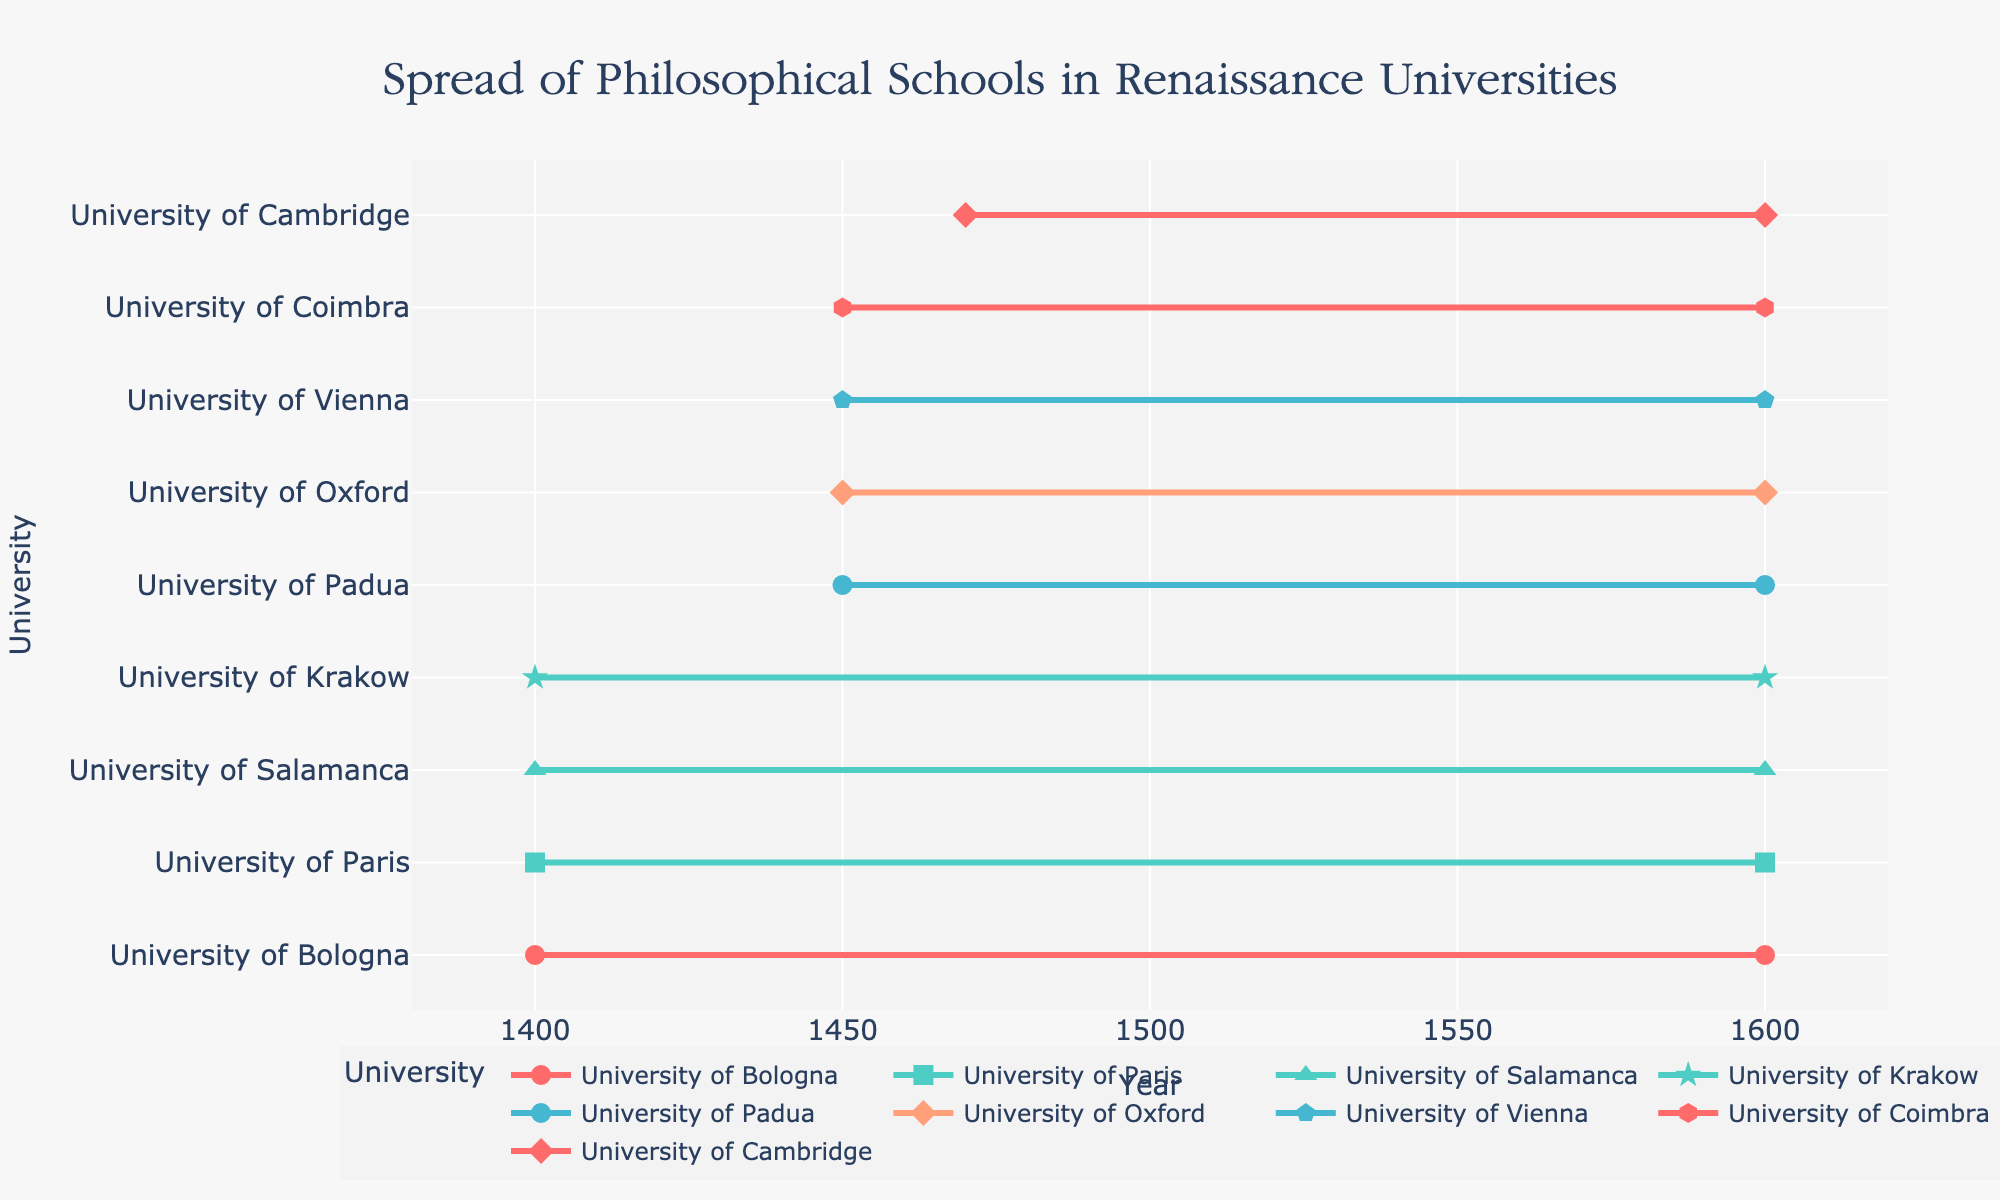What is the time range covered by Aristotelianism at the University of Bologna? The University of Bologna shows a time range from 1400 to 1600 for Aristotelianism. This can be observed by looking at the endpoints of the line corresponding to the University of Bologna and checking the start and end years.
Answer: 1400-1600 Which university earliest adopted Humanism according to the plot? By observing the starting points of the Humanism lines, the University of Padua has the earliest start year for Humanism in 1450.
Answer: University of Padua Which universities adopted Scholasticism? By examining the labels and corresponding hover text, we see that the University of Paris, University of Salamanca, and University of Krakow had lines corresponding to Scholasticism.
Answer: University of Paris, University of Salamanca, University of Krakow Which university's adoption period lasted the longest? By comparing the lengths of the lines, it's clear that the University of Bologna (Aristotelianism), University of Paris (Scholasticism), University of Salamanca (Scholasticism), and University of Krakow (Scholasticism) each have lines starting in 1400 and ending in 1600, hence lasting 200 years.
Answer: University of Bologna, University of Paris, University of Salamanca, University of Krakow Which philosophical school of thought was adopted by the most universities? By counting the lines, we see Aristotelianism appears in University of Bologna, University of Cambridge, and University of Coimbra, which makes 3 instances, thus presenting the highest count compared to other schools.
Answer: Aristotelianism What is the average start year for Platonism? Since Platonism is only adopted by the University of Oxford, which starts in 1450, the average start year is calculated with only this data point.
Answer: 1450 Which philosophical school is represented by the most diverse set of countries? Observing the number of unique countries for each school, Humanism (adopted by universities in Italy and Austria) has 2 unique countries, which is more than other schools of thought.
Answer: Humanism What are the symbols used to represent universities from Italy? By checking the symbol associated with Italian universities (University of Bologna and University of Padua) in the legend, they are represented by circles.
Answer: Circle Which university has the latest end year for its given school of thought? All universities have an end year of 1600 for their respective schools of thought, so no single university ends later than the others.
Answer: All end in 1600 